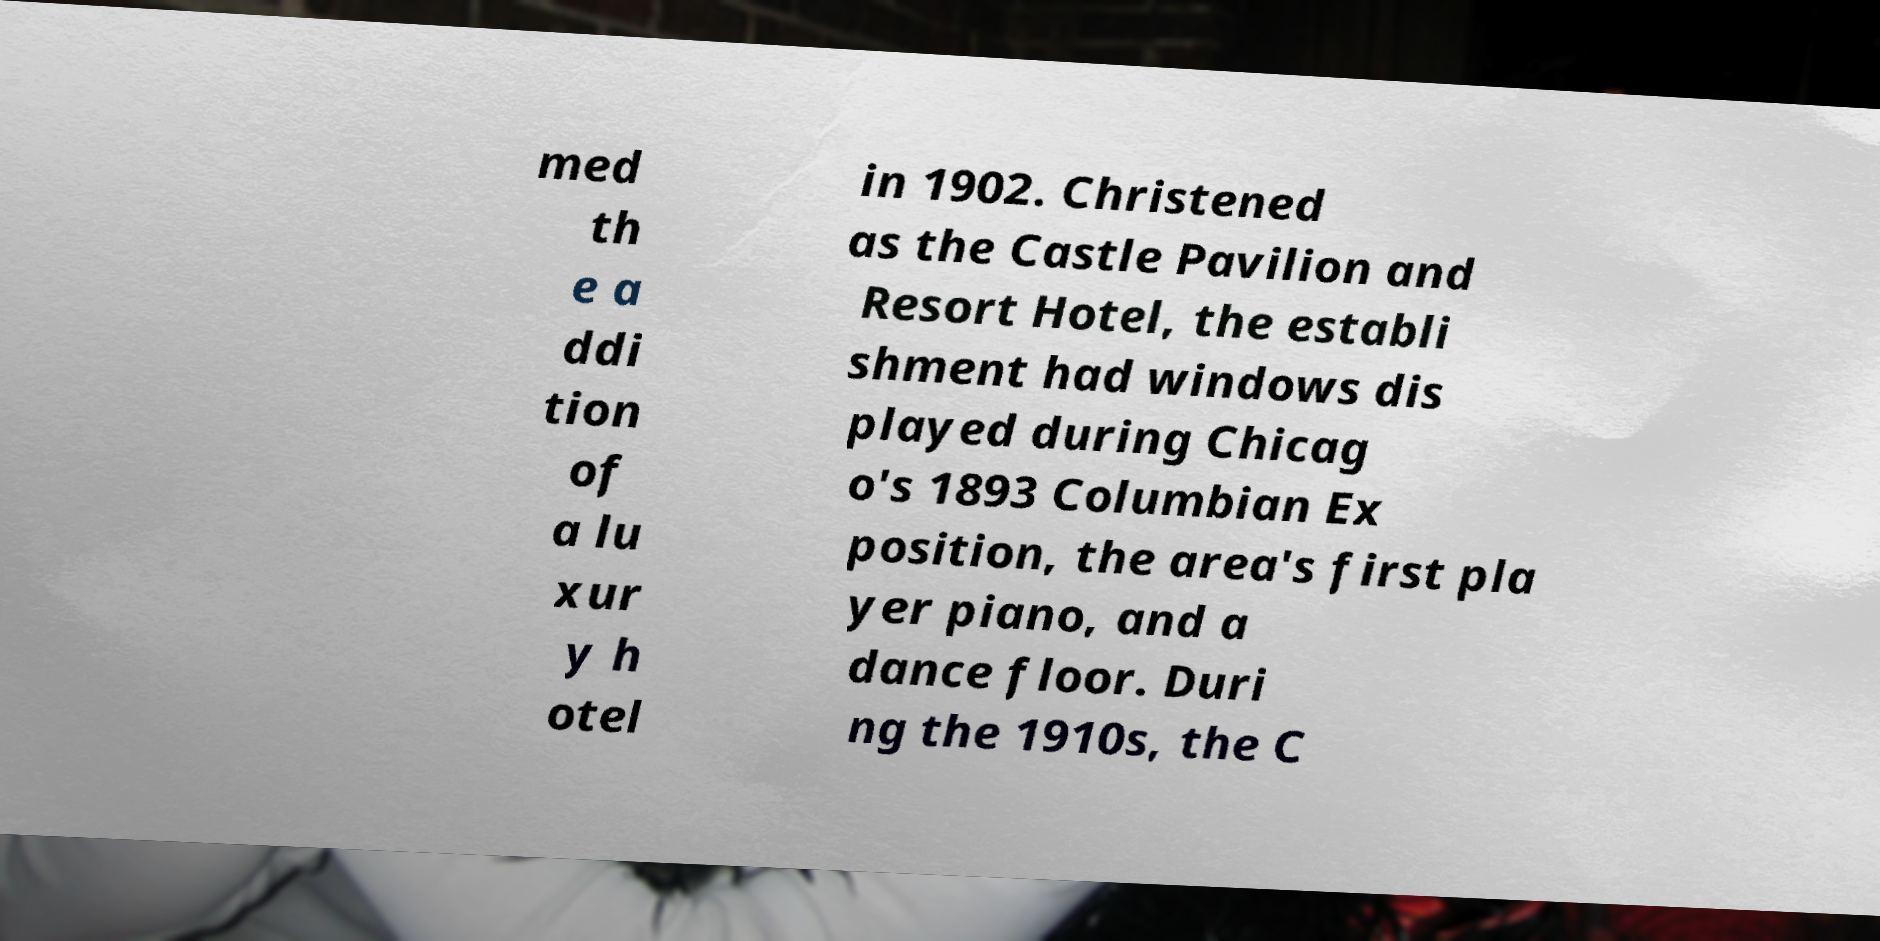I need the written content from this picture converted into text. Can you do that? med th e a ddi tion of a lu xur y h otel in 1902. Christened as the Castle Pavilion and Resort Hotel, the establi shment had windows dis played during Chicag o's 1893 Columbian Ex position, the area's first pla yer piano, and a dance floor. Duri ng the 1910s, the C 